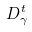Convert formula to latex. <formula><loc_0><loc_0><loc_500><loc_500>D _ { \gamma } ^ { t }</formula> 